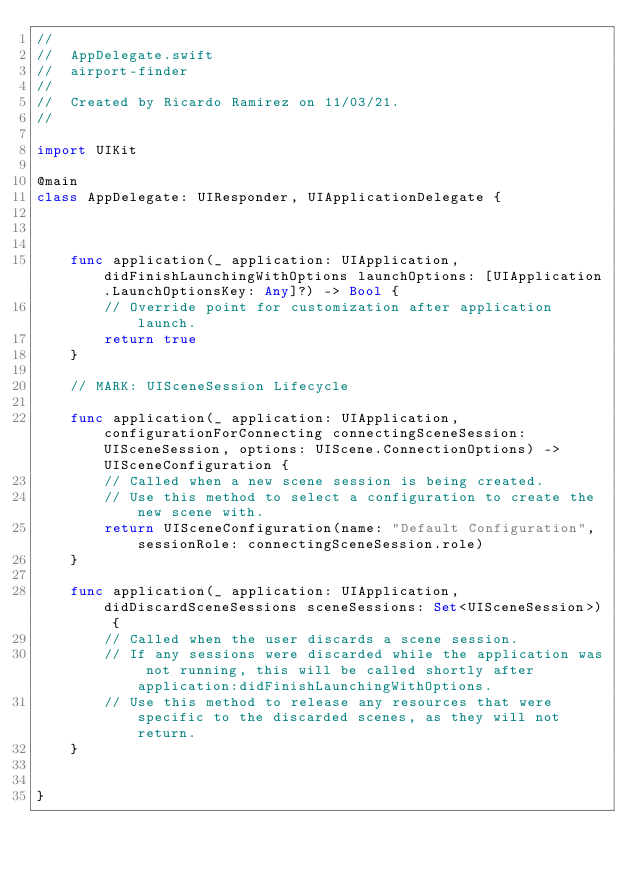Convert code to text. <code><loc_0><loc_0><loc_500><loc_500><_Swift_>//
//  AppDelegate.swift
//  airport-finder
//
//  Created by Ricardo Ramirez on 11/03/21.
//

import UIKit

@main
class AppDelegate: UIResponder, UIApplicationDelegate {



    func application(_ application: UIApplication, didFinishLaunchingWithOptions launchOptions: [UIApplication.LaunchOptionsKey: Any]?) -> Bool {
        // Override point for customization after application launch.
        return true
    }

    // MARK: UISceneSession Lifecycle

    func application(_ application: UIApplication, configurationForConnecting connectingSceneSession: UISceneSession, options: UIScene.ConnectionOptions) -> UISceneConfiguration {
        // Called when a new scene session is being created.
        // Use this method to select a configuration to create the new scene with.
        return UISceneConfiguration(name: "Default Configuration", sessionRole: connectingSceneSession.role)
    }

    func application(_ application: UIApplication, didDiscardSceneSessions sceneSessions: Set<UISceneSession>) {
        // Called when the user discards a scene session.
        // If any sessions were discarded while the application was not running, this will be called shortly after application:didFinishLaunchingWithOptions.
        // Use this method to release any resources that were specific to the discarded scenes, as they will not return.
    }


}

</code> 